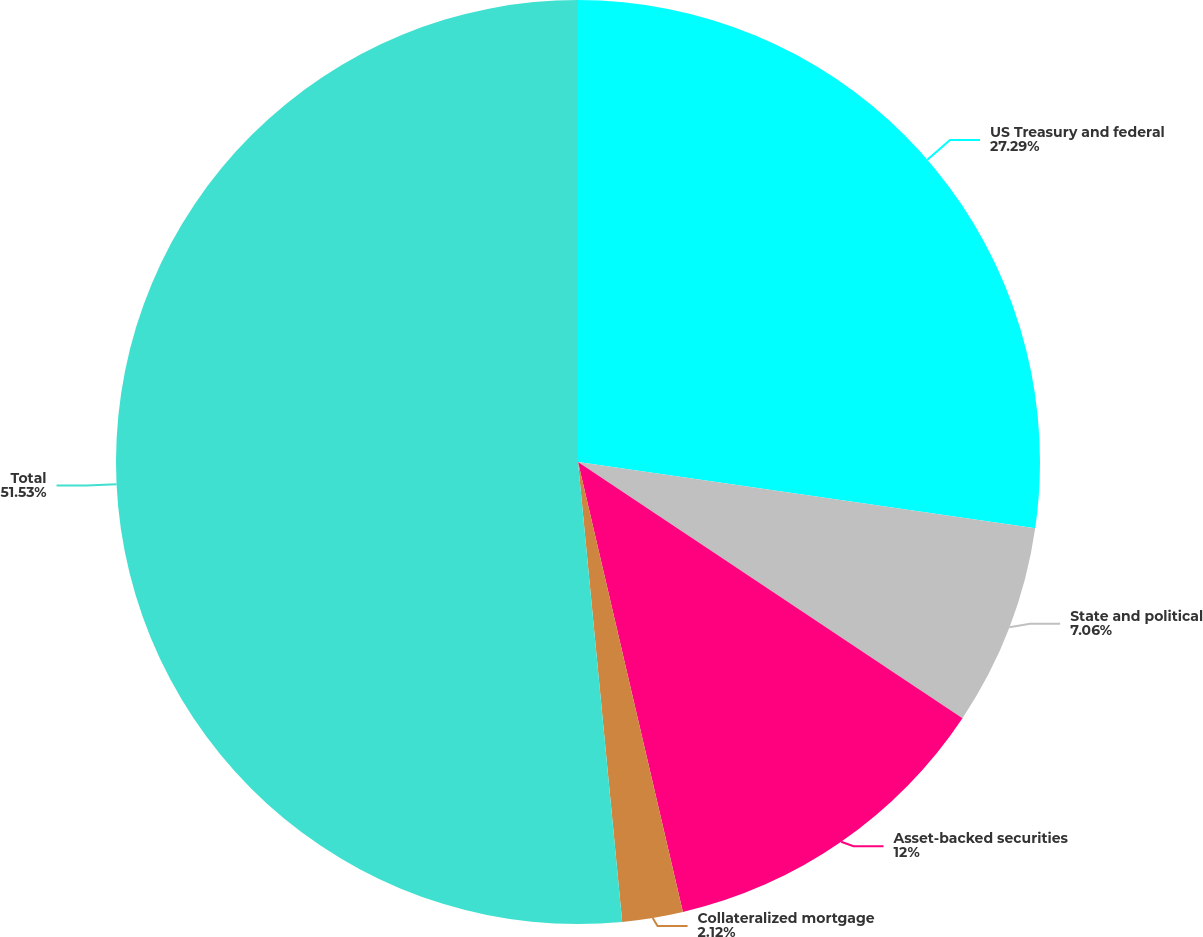Convert chart. <chart><loc_0><loc_0><loc_500><loc_500><pie_chart><fcel>US Treasury and federal<fcel>State and political<fcel>Asset-backed securities<fcel>Collateralized mortgage<fcel>Total<nl><fcel>27.29%<fcel>7.06%<fcel>12.0%<fcel>2.12%<fcel>51.52%<nl></chart> 